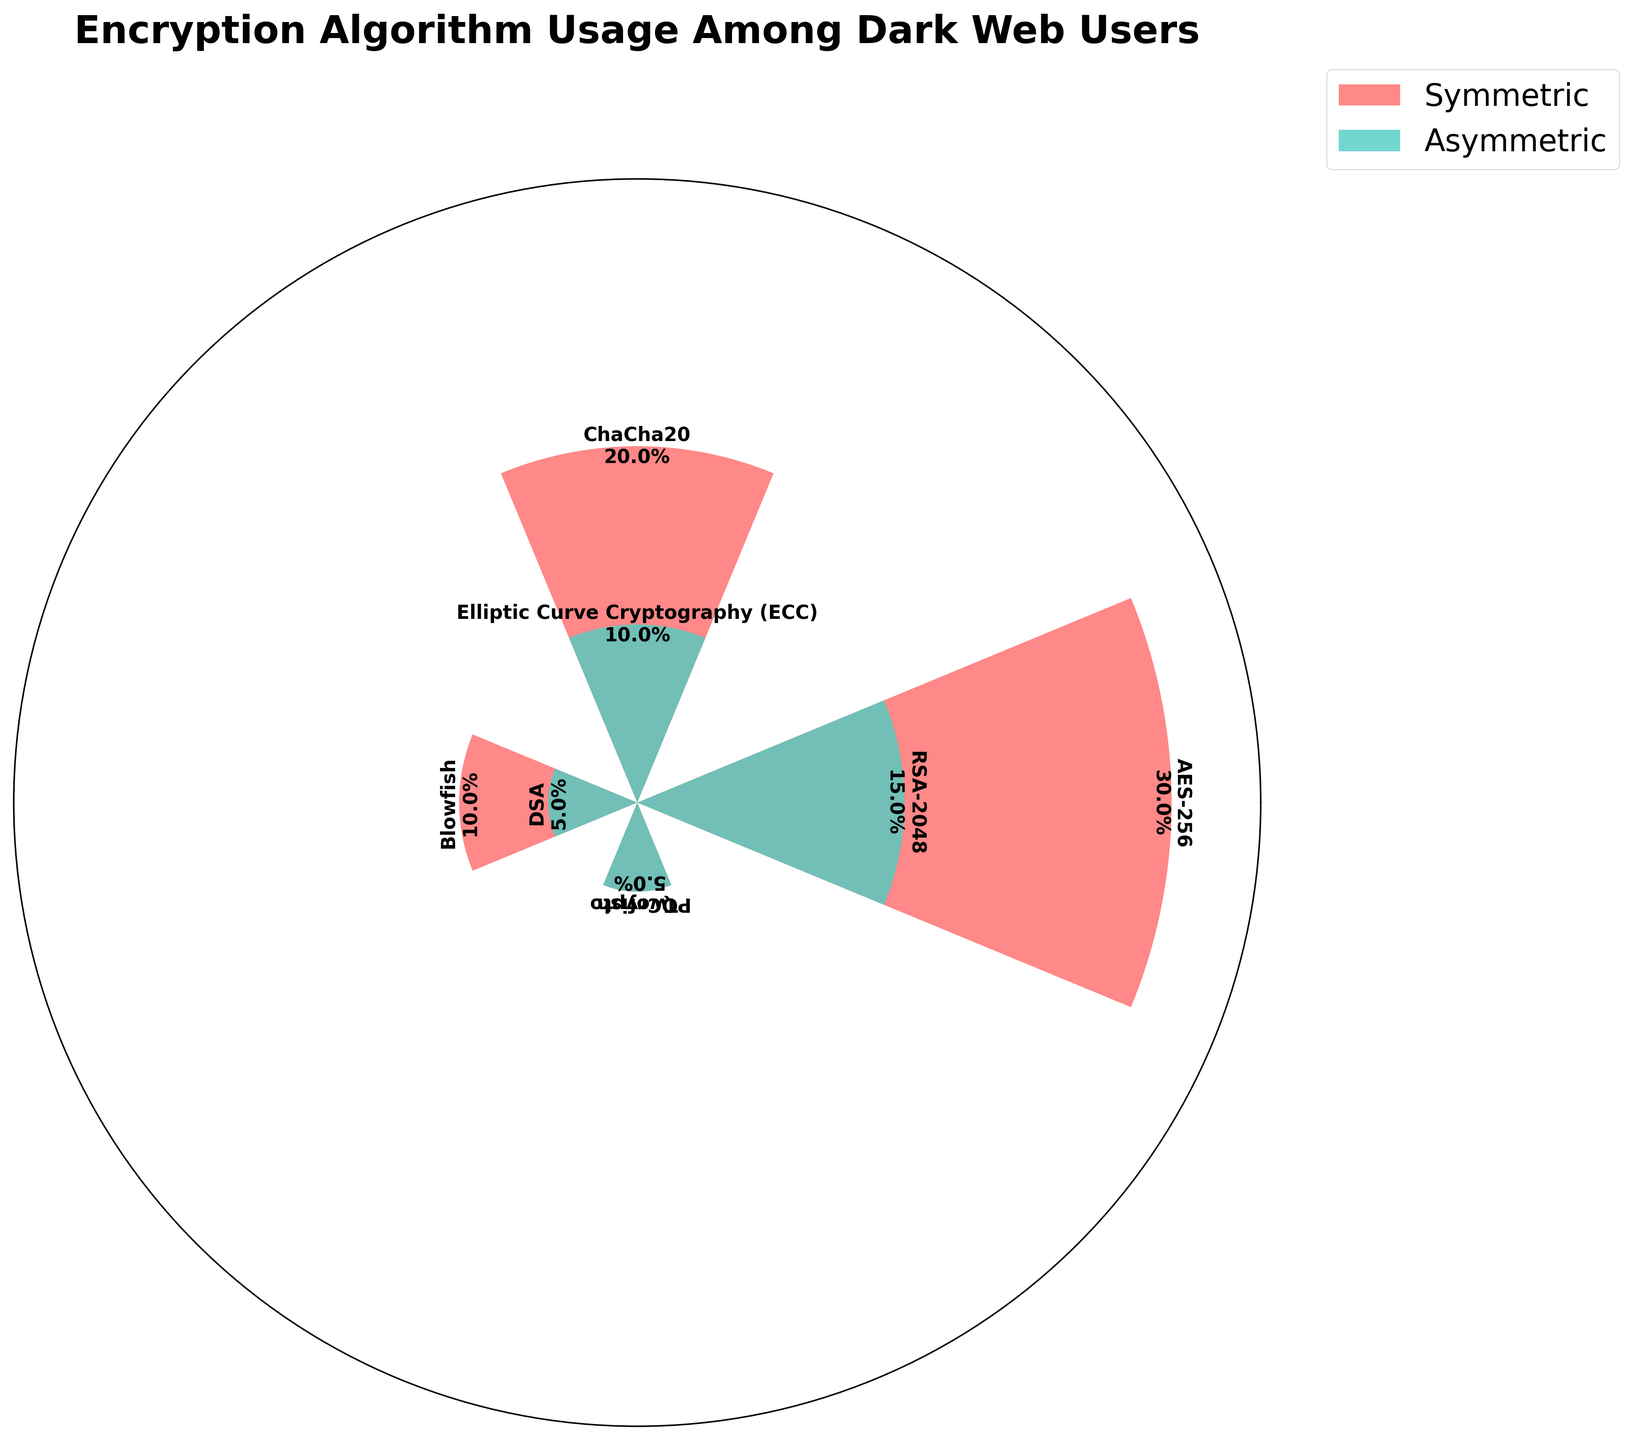What is the title of the chart? The title of the chart is the text displayed at the top. Reading it, we see that it says "Encryption Algorithm Usage Among Dark Web Users."
Answer: Encryption Algorithm Usage Among Dark Web Users How many algorithms are displayed in the chart? Each bar in the chart represents an algorithm. Counting these, we find there are 8 different bars.
Answer: 8 Which symmetric algorithm has the highest usage percentage? In the polar chart, the bars for symmetric methods can be identified by their color. Among these, the AES-256 bar is the tallest, indicating the highest usage percentage.
Answer: AES-256 What is the combined usage percentage of ChaCha20 and Twofish? First, identify the bars for ChaCha20 and Twofish. ChaCha20 has a usage percentage of 20%, and Twofish has 5%. Adding these together, the combined usage percentage is 20% + 5% = 25%.
Answer: 25% Which asymmetric algorithm has a higher usage percentage, RSA-2048 or PQCrypto? To compare RSA-2048 and PQCrypto, find their bars in the chart. The RSA-2048 bar is clearly taller with a 15% usage, while PQCrypto has a 5% usage. Therefore, RSA-2048 has a higher usage percentage.
Answer: RSA-2048 Are the total usage percentages for symmetric and asymmetric methods equal? Sum the usage percentages for the symmetric and asymmetric methods separately. For symmetric: 30% (AES-256) + 20% (ChaCha20) + 10% (Blowfish) + 5% (Twofish) = 65%. For asymmetric: 15% (RSA-2048) + 10% (ECC) + 5% (DSA) + 5% (PQCrypto) = 35%. They are not equal.
Answer: No What is the average usage percentage of all asymmetric algorithms? Sum the usage percentages of all asymmetric algorithms and divide by their number. (15% + 10% + 5% + 5%) / 4 = 35% / 4 = 8.75%.
Answer: 8.75% How does the usage of ECC compare to that of Blowfish? Find their bars in the chart. ECC has a usage percentage of 10%, and Blowfish also has 10%. They are equal.
Answer: Equal Which method has more total usage, symmetric or asymmetric? Sum up the total usage for symmetric and asymmetric methods. Symmetric totals to 65% and asymmetric totals to 35%. Symmetric has more total usage.
Answer: Symmetric 